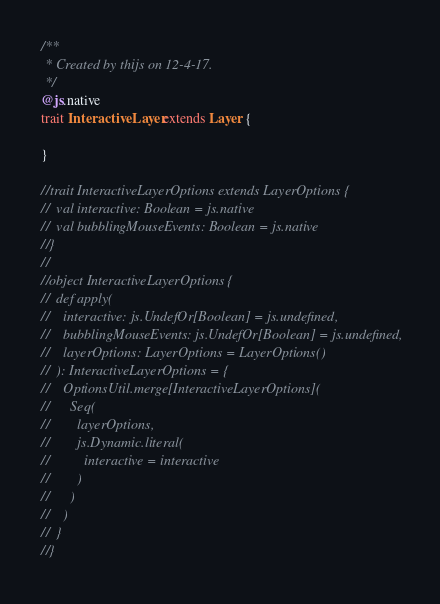Convert code to text. <code><loc_0><loc_0><loc_500><loc_500><_Scala_>/**
 * Created by thijs on 12-4-17.
 */
@js.native
trait InteractiveLayer extends Layer {

}

//trait InteractiveLayerOptions extends LayerOptions {
//  val interactive: Boolean = js.native
//  val bubblingMouseEvents: Boolean = js.native
//}
//
//object InteractiveLayerOptions {
//  def apply(
//    interactive: js.UndefOr[Boolean] = js.undefined,
//    bubblingMouseEvents: js.UndefOr[Boolean] = js.undefined,
//    layerOptions: LayerOptions = LayerOptions()
//  ): InteractiveLayerOptions = {
//    OptionsUtil.merge[InteractiveLayerOptions](
//      Seq(
//        layerOptions,
//        js.Dynamic.literal(
//          interactive = interactive
//        )
//      )
//    )
//  }
//}
</code> 